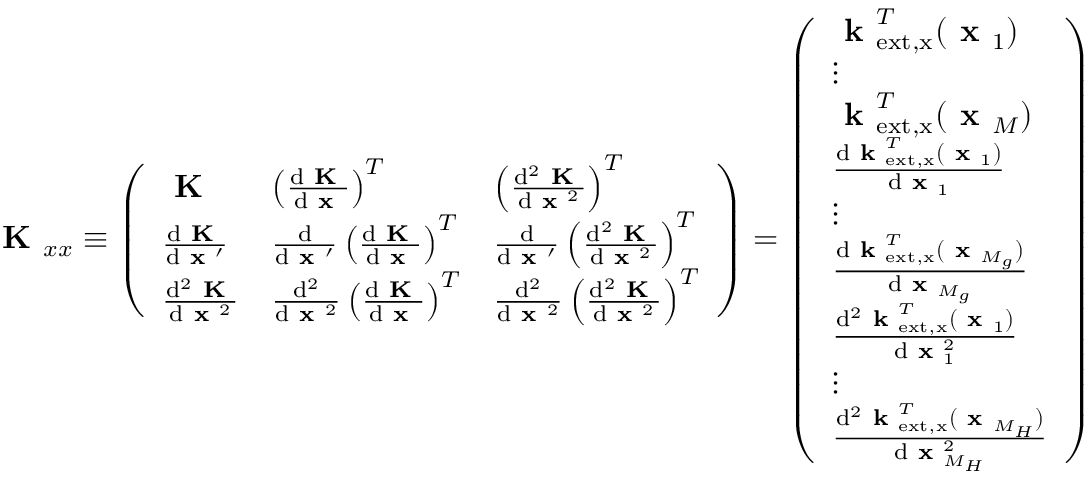Convert formula to latex. <formula><loc_0><loc_0><loc_500><loc_500>K _ { x x } \equiv \left ( \begin{array} { l l l } { K } & { \left ( \frac { d K } { d x } \right ) ^ { T } } & { \left ( \frac { d ^ { 2 } K } { d x ^ { 2 } } \right ) ^ { T } } \\ { \frac { d K } { d x ^ { \prime } } } & { \frac { d } { d x ^ { \prime } } \left ( \frac { d K } { d x } \right ) ^ { T } } & { \frac { d } { d x ^ { \prime } } \left ( \frac { d ^ { 2 } K } { d x ^ { 2 } } \right ) ^ { T } } \\ { \frac { d ^ { 2 } K } { d x ^ { 2 } } } & { \frac { d ^ { 2 } } { d x ^ { 2 } } \left ( \frac { d K } { d x } \right ) ^ { T } } & { \frac { d ^ { 2 } } { d x ^ { 2 } } \left ( \frac { d ^ { 2 } K } { d x ^ { 2 } } \right ) ^ { T } } \end{array} \right ) = \left ( \begin{array} { l } { k _ { e x t , x } ^ { T } ( x _ { 1 } ) } \\ { \vdots } \\ { k _ { e x t , x } ^ { T } ( x _ { M } ) } \\ { \frac { d k _ { e x t , x } ^ { T } ( x _ { 1 } ) } { d x _ { 1 } } } \\ { \vdots } \\ { \frac { d k _ { e x t , x } ^ { T } ( x _ { M _ { g } } ) } { d x _ { M _ { g } } } } \\ { \frac { d ^ { 2 } k _ { e x t , x } ^ { T } ( x _ { 1 } ) } { d x _ { 1 } ^ { 2 } } } \\ { \vdots } \\ { \frac { d ^ { 2 } k _ { e x t , x } ^ { T } ( x _ { M _ { H } } ) } { d x _ { M _ { H } } ^ { 2 } } } \end{array} \right )</formula> 